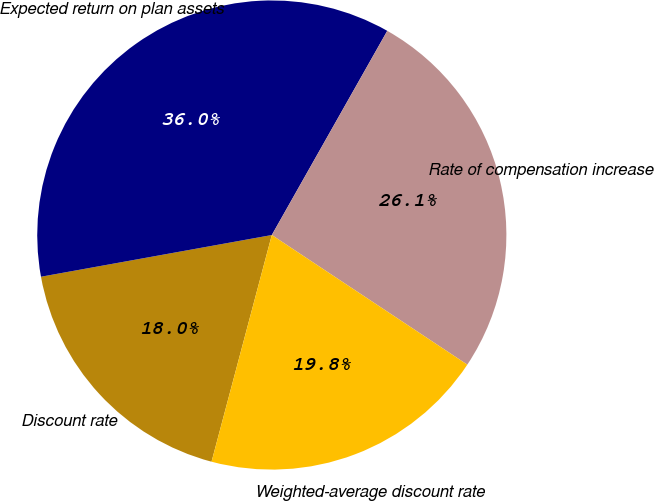Convert chart to OTSL. <chart><loc_0><loc_0><loc_500><loc_500><pie_chart><fcel>Discount rate<fcel>Expected return on plan assets<fcel>Rate of compensation increase<fcel>Weighted-average discount rate<nl><fcel>18.02%<fcel>36.04%<fcel>26.13%<fcel>19.82%<nl></chart> 